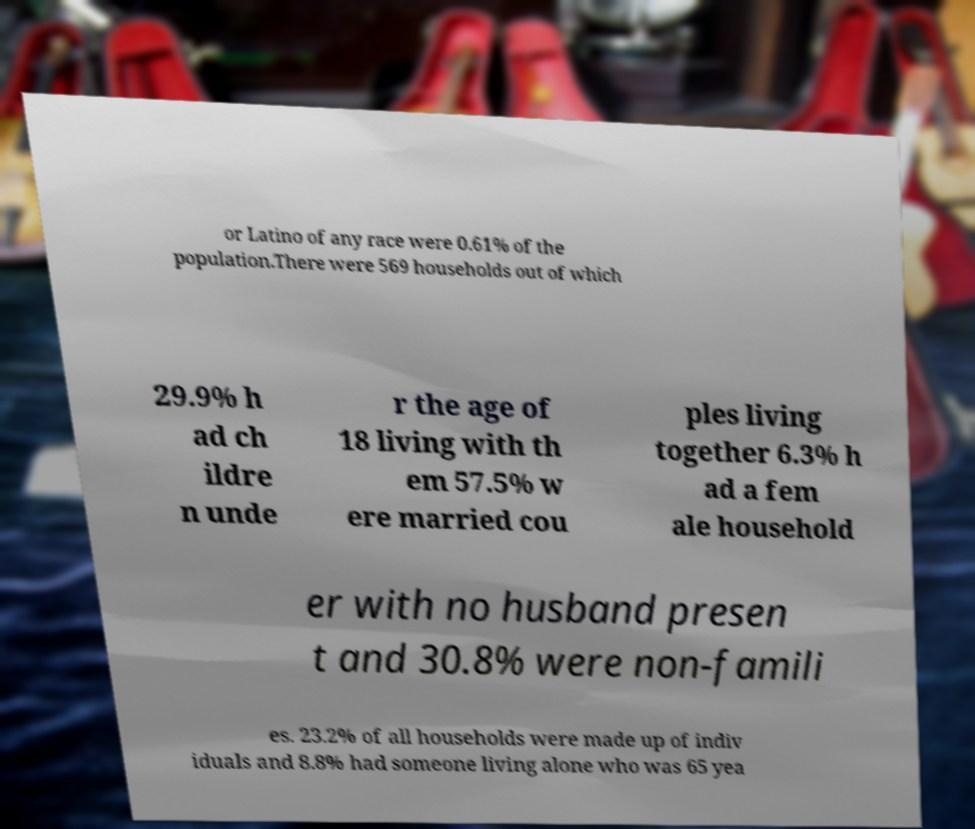Please read and relay the text visible in this image. What does it say? or Latino of any race were 0.61% of the population.There were 569 households out of which 29.9% h ad ch ildre n unde r the age of 18 living with th em 57.5% w ere married cou ples living together 6.3% h ad a fem ale household er with no husband presen t and 30.8% were non-famili es. 23.2% of all households were made up of indiv iduals and 8.8% had someone living alone who was 65 yea 